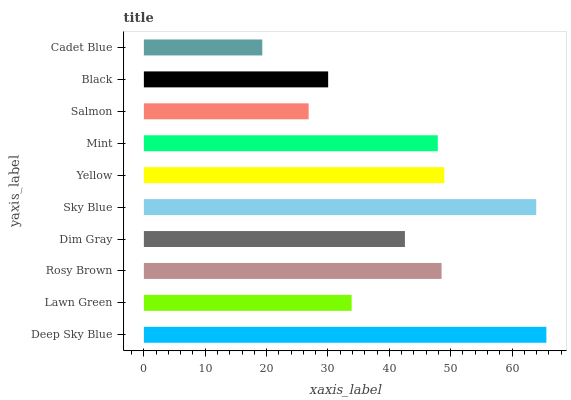Is Cadet Blue the minimum?
Answer yes or no. Yes. Is Deep Sky Blue the maximum?
Answer yes or no. Yes. Is Lawn Green the minimum?
Answer yes or no. No. Is Lawn Green the maximum?
Answer yes or no. No. Is Deep Sky Blue greater than Lawn Green?
Answer yes or no. Yes. Is Lawn Green less than Deep Sky Blue?
Answer yes or no. Yes. Is Lawn Green greater than Deep Sky Blue?
Answer yes or no. No. Is Deep Sky Blue less than Lawn Green?
Answer yes or no. No. Is Mint the high median?
Answer yes or no. Yes. Is Dim Gray the low median?
Answer yes or no. Yes. Is Lawn Green the high median?
Answer yes or no. No. Is Lawn Green the low median?
Answer yes or no. No. 